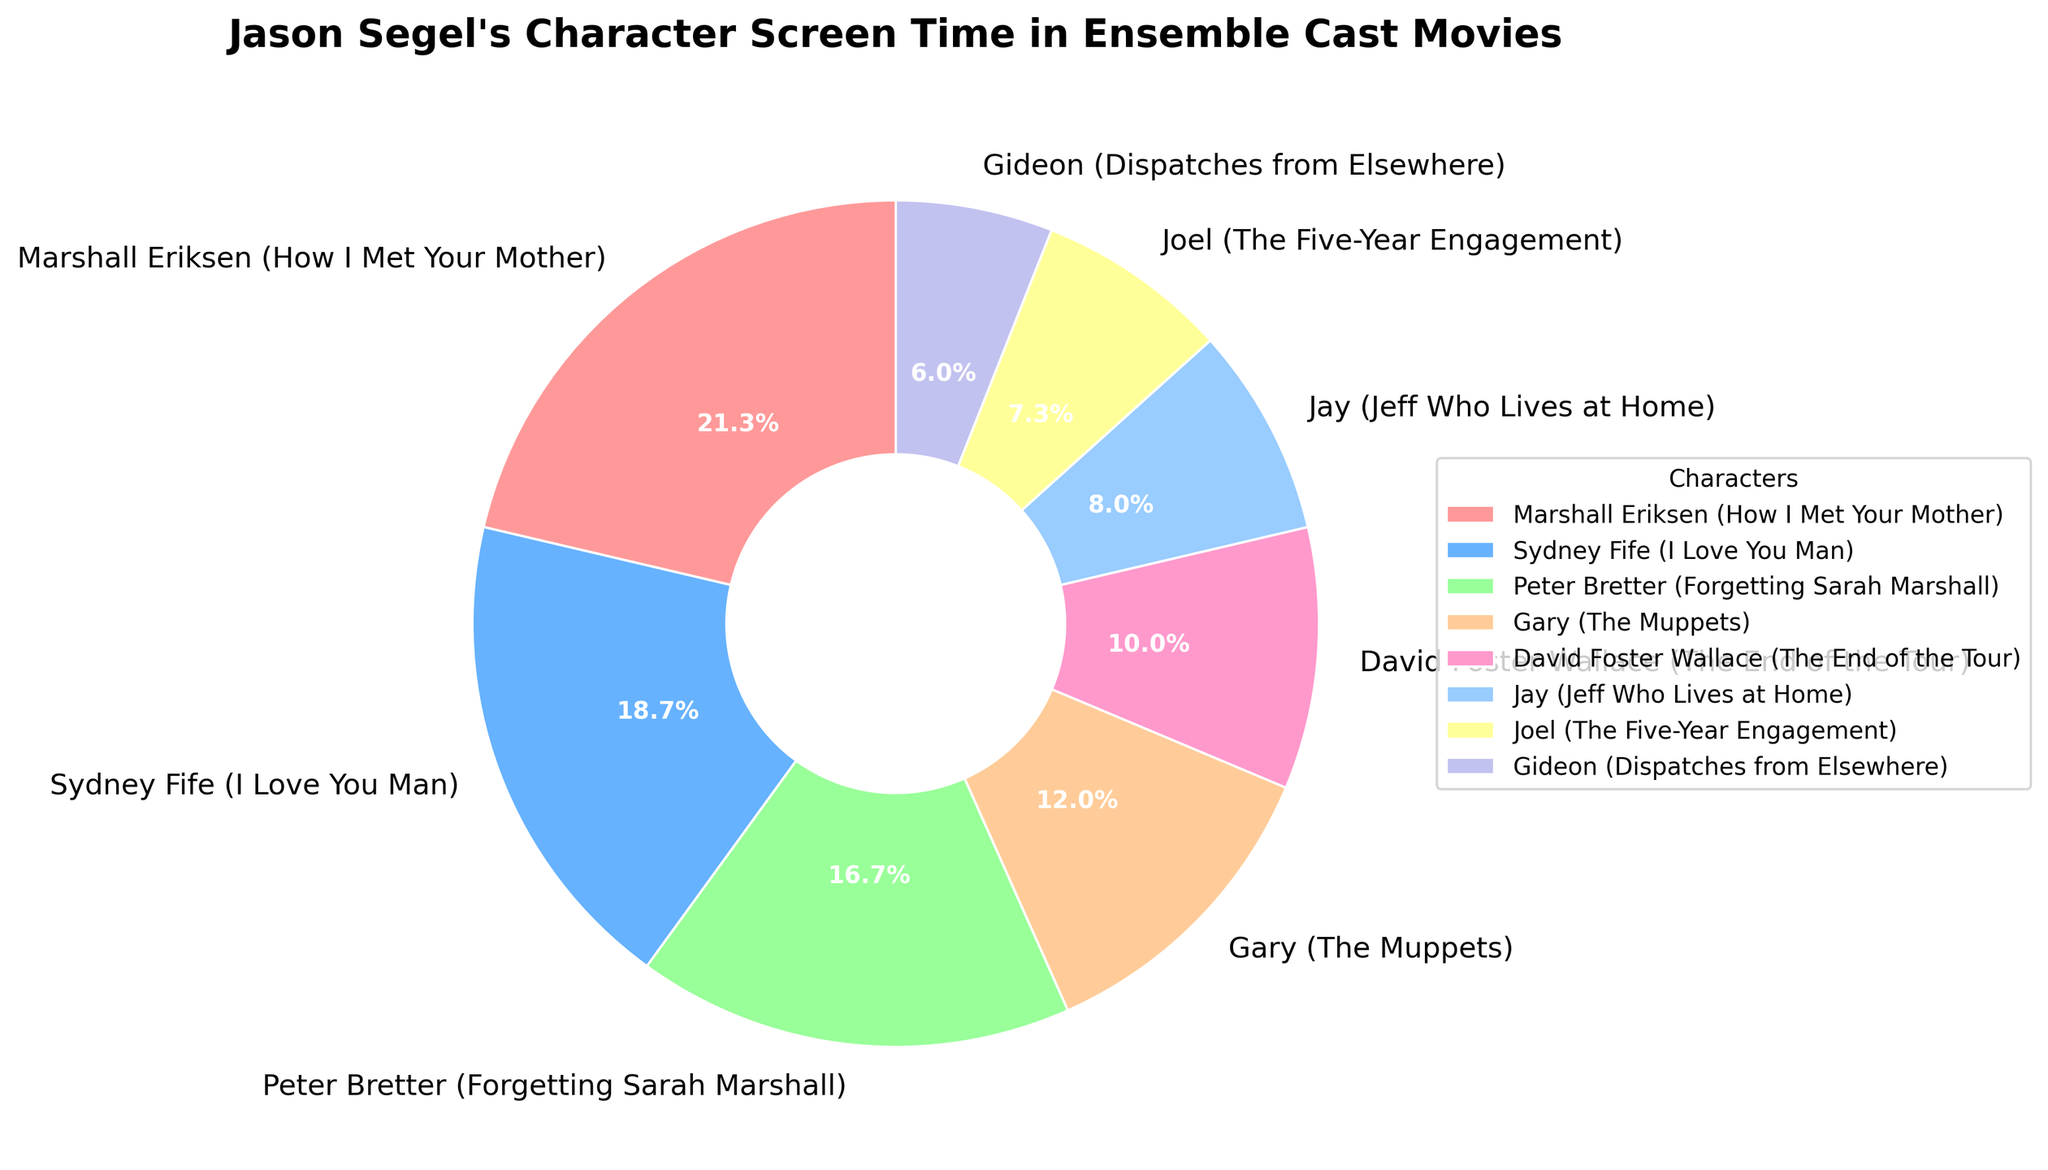Which character has the highest screen time percentage? To find this out, look at the pie chart segments and identify the one with the largest portion. The character name is labeled directly on the chart.
Answer: Marshall Eriksen (How I Met Your Mother) Which character has the smallest screen time percentage? Look for the smallest slice in the pie chart and read the associated character name.
Answer: Gideon (Dispatches from Elsewhere) How much more screen time does Marshall Eriksen have compared to Joel? Identify the percentages for Marshall Eriksen and Joel from the chart, then subtract Joel's percentage from Marshall Eriksen's percentage: 32% - 11% = 21%.
Answer: 21% Which character has a slightly higher screen time, Gary or David Foster Wallace? Find the sections for Gary and David Foster Wallace on the chart. Compare their screen time percentages: Gary with 18% and David Foster Wallace with 15%.
Answer: Gary What is the total screen time percentage for Sydney Fife, Peter Bretter, and Gary combined? Sum the percentages for Sydney Fife, Peter Bretter, and Gary: 28% + 25% + 18% = 71%.
Answer: 71% What is the difference in screen time percentage between the character with the most screen time and the character with the least? Find the percentages for the character with the most screen time (Marshall Eriksen with 32%) and the character with the least screen time (Gideon with 9%) and subtract: 32% - 9% = 23%.
Answer: 23% How much is the combined screen time percentage of all characters with less than 20% screen time each? Identify characters with less than 20% screen time and sum their percentages: Gary (18%), David Foster Wallace (15%), Jay (12%), Joel (11%), Gideon (9%): 18% + 15% + 12% + 11% + 9% = 65%.
Answer: 65% Which color represents Peter Bretter? Look at the pie chart and find the color segment labeled "Peter Bretter."
Answer: Blue Is Sydney Fife's screen time percentage greater than the combined screen time percentage of Jay and Joel? Calculate the combined screen time of Jay and Joel: 12% + 11% = 23% and compare it to Sydney Fife's 28%. Since 28% > 23%, the answer is yes.
Answer: Yes 